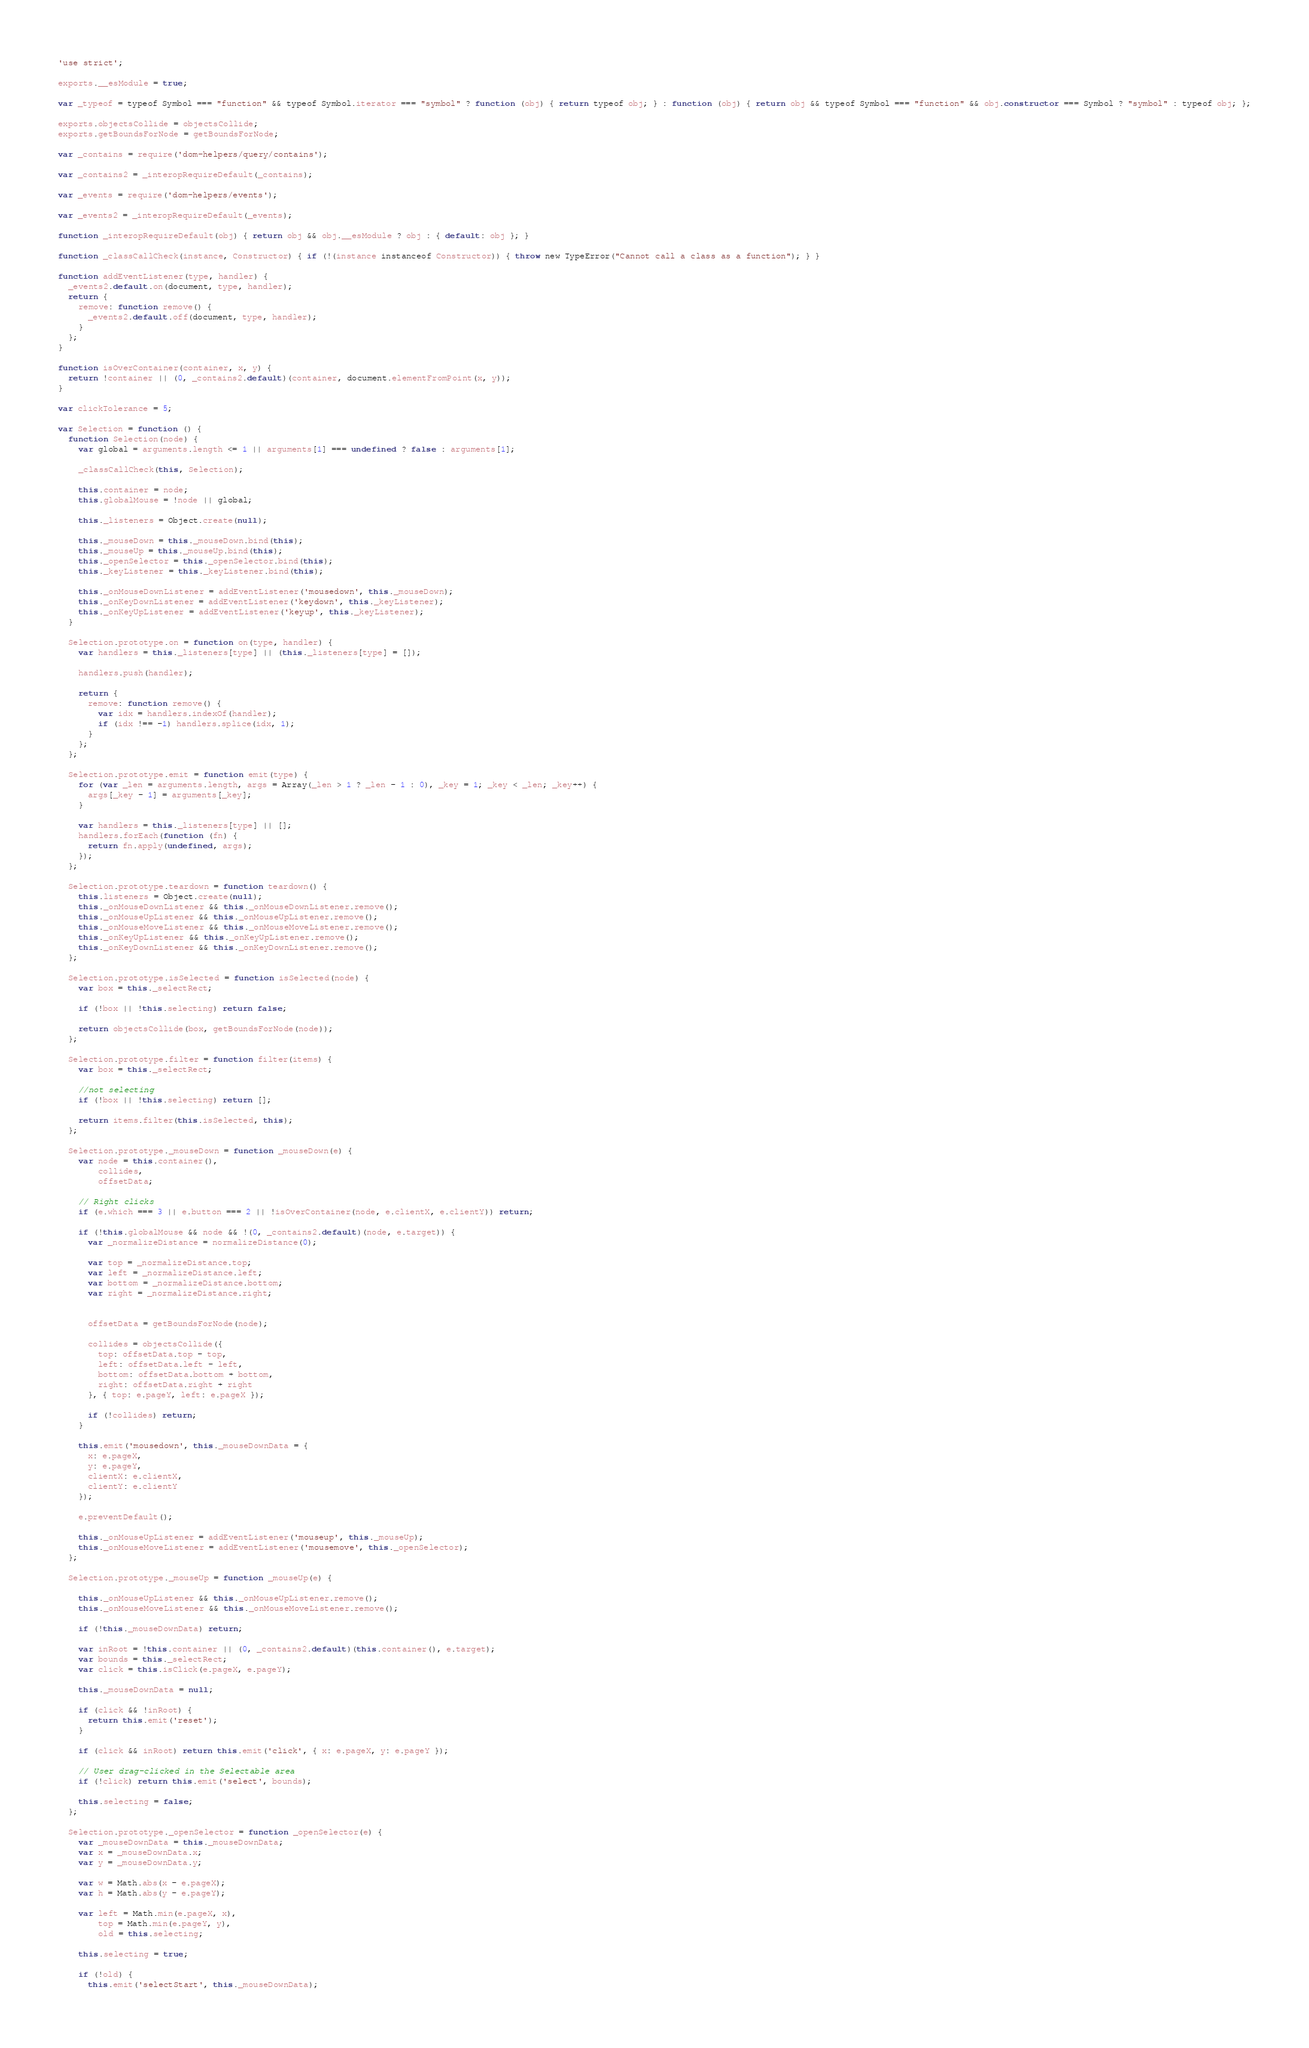<code> <loc_0><loc_0><loc_500><loc_500><_JavaScript_>'use strict';

exports.__esModule = true;

var _typeof = typeof Symbol === "function" && typeof Symbol.iterator === "symbol" ? function (obj) { return typeof obj; } : function (obj) { return obj && typeof Symbol === "function" && obj.constructor === Symbol ? "symbol" : typeof obj; };

exports.objectsCollide = objectsCollide;
exports.getBoundsForNode = getBoundsForNode;

var _contains = require('dom-helpers/query/contains');

var _contains2 = _interopRequireDefault(_contains);

var _events = require('dom-helpers/events');

var _events2 = _interopRequireDefault(_events);

function _interopRequireDefault(obj) { return obj && obj.__esModule ? obj : { default: obj }; }

function _classCallCheck(instance, Constructor) { if (!(instance instanceof Constructor)) { throw new TypeError("Cannot call a class as a function"); } }

function addEventListener(type, handler) {
  _events2.default.on(document, type, handler);
  return {
    remove: function remove() {
      _events2.default.off(document, type, handler);
    }
  };
}

function isOverContainer(container, x, y) {
  return !container || (0, _contains2.default)(container, document.elementFromPoint(x, y));
}

var clickTolerance = 5;

var Selection = function () {
  function Selection(node) {
    var global = arguments.length <= 1 || arguments[1] === undefined ? false : arguments[1];

    _classCallCheck(this, Selection);

    this.container = node;
    this.globalMouse = !node || global;

    this._listeners = Object.create(null);

    this._mouseDown = this._mouseDown.bind(this);
    this._mouseUp = this._mouseUp.bind(this);
    this._openSelector = this._openSelector.bind(this);
    this._keyListener = this._keyListener.bind(this);

    this._onMouseDownListener = addEventListener('mousedown', this._mouseDown);
    this._onKeyDownListener = addEventListener('keydown', this._keyListener);
    this._onKeyUpListener = addEventListener('keyup', this._keyListener);
  }

  Selection.prototype.on = function on(type, handler) {
    var handlers = this._listeners[type] || (this._listeners[type] = []);

    handlers.push(handler);

    return {
      remove: function remove() {
        var idx = handlers.indexOf(handler);
        if (idx !== -1) handlers.splice(idx, 1);
      }
    };
  };

  Selection.prototype.emit = function emit(type) {
    for (var _len = arguments.length, args = Array(_len > 1 ? _len - 1 : 0), _key = 1; _key < _len; _key++) {
      args[_key - 1] = arguments[_key];
    }

    var handlers = this._listeners[type] || [];
    handlers.forEach(function (fn) {
      return fn.apply(undefined, args);
    });
  };

  Selection.prototype.teardown = function teardown() {
    this.listeners = Object.create(null);
    this._onMouseDownListener && this._onMouseDownListener.remove();
    this._onMouseUpListener && this._onMouseUpListener.remove();
    this._onMouseMoveListener && this._onMouseMoveListener.remove();
    this._onKeyUpListener && this._onKeyUpListener.remove();
    this._onKeyDownListener && this._onKeyDownListener.remove();
  };

  Selection.prototype.isSelected = function isSelected(node) {
    var box = this._selectRect;

    if (!box || !this.selecting) return false;

    return objectsCollide(box, getBoundsForNode(node));
  };

  Selection.prototype.filter = function filter(items) {
    var box = this._selectRect;

    //not selecting
    if (!box || !this.selecting) return [];

    return items.filter(this.isSelected, this);
  };

  Selection.prototype._mouseDown = function _mouseDown(e) {
    var node = this.container(),
        collides,
        offsetData;

    // Right clicks
    if (e.which === 3 || e.button === 2 || !isOverContainer(node, e.clientX, e.clientY)) return;

    if (!this.globalMouse && node && !(0, _contains2.default)(node, e.target)) {
      var _normalizeDistance = normalizeDistance(0);

      var top = _normalizeDistance.top;
      var left = _normalizeDistance.left;
      var bottom = _normalizeDistance.bottom;
      var right = _normalizeDistance.right;


      offsetData = getBoundsForNode(node);

      collides = objectsCollide({
        top: offsetData.top - top,
        left: offsetData.left - left,
        bottom: offsetData.bottom + bottom,
        right: offsetData.right + right
      }, { top: e.pageY, left: e.pageX });

      if (!collides) return;
    }

    this.emit('mousedown', this._mouseDownData = {
      x: e.pageX,
      y: e.pageY,
      clientX: e.clientX,
      clientY: e.clientY
    });

    e.preventDefault();

    this._onMouseUpListener = addEventListener('mouseup', this._mouseUp);
    this._onMouseMoveListener = addEventListener('mousemove', this._openSelector);
  };

  Selection.prototype._mouseUp = function _mouseUp(e) {

    this._onMouseUpListener && this._onMouseUpListener.remove();
    this._onMouseMoveListener && this._onMouseMoveListener.remove();

    if (!this._mouseDownData) return;

    var inRoot = !this.container || (0, _contains2.default)(this.container(), e.target);
    var bounds = this._selectRect;
    var click = this.isClick(e.pageX, e.pageY);

    this._mouseDownData = null;

    if (click && !inRoot) {
      return this.emit('reset');
    }

    if (click && inRoot) return this.emit('click', { x: e.pageX, y: e.pageY });

    // User drag-clicked in the Selectable area
    if (!click) return this.emit('select', bounds);

    this.selecting = false;
  };

  Selection.prototype._openSelector = function _openSelector(e) {
    var _mouseDownData = this._mouseDownData;
    var x = _mouseDownData.x;
    var y = _mouseDownData.y;

    var w = Math.abs(x - e.pageX);
    var h = Math.abs(y - e.pageY);

    var left = Math.min(e.pageX, x),
        top = Math.min(e.pageY, y),
        old = this.selecting;

    this.selecting = true;

    if (!old) {
      this.emit('selectStart', this._mouseDownData);</code> 